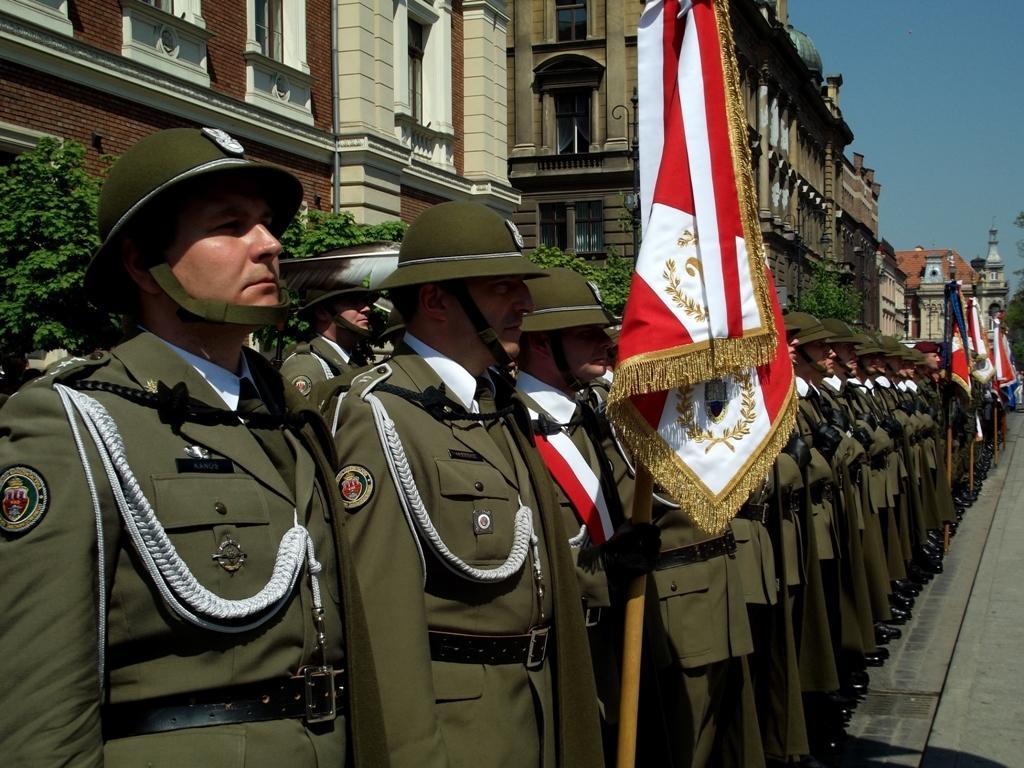Could you give a brief overview of what you see in this image? In the picture there are a group of people standing in a row, all of them are wearing same uniform and some of them are holding flags, behind them there are many plants and behind the plants there are buildings. 